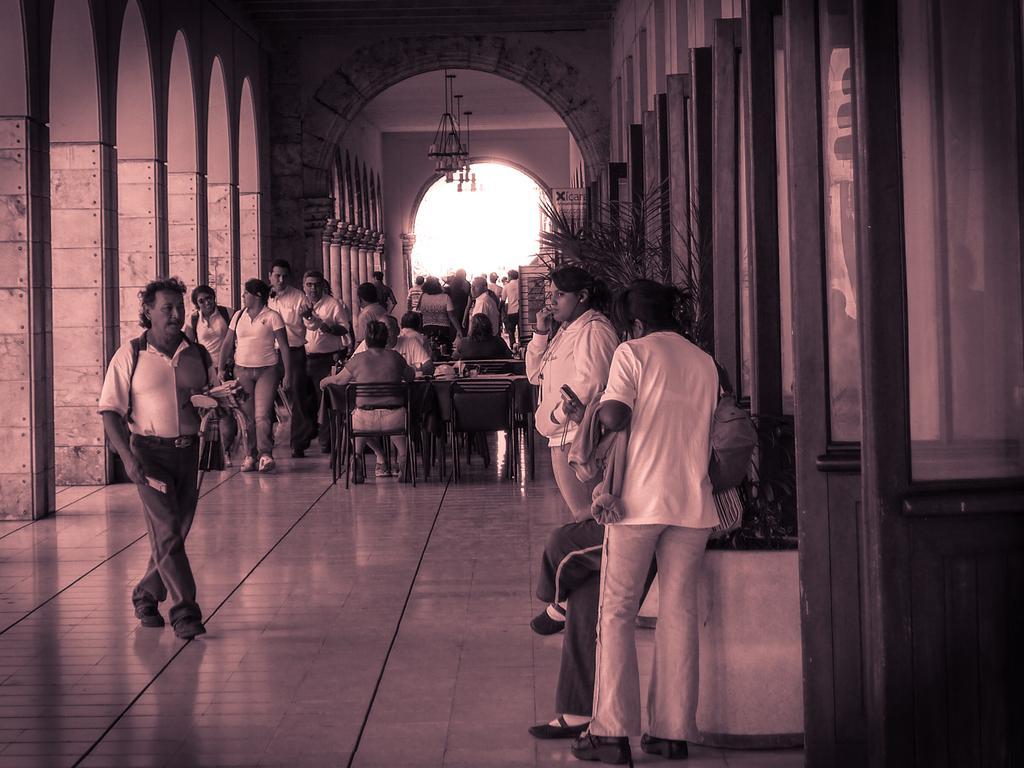In one or two sentences, can you explain what this image depicts? This is an edited image. In this image we can see a group of people on the floor. We can also see some people sitting on the chairs, some pillars, chandeliers to a roof and the sky. 